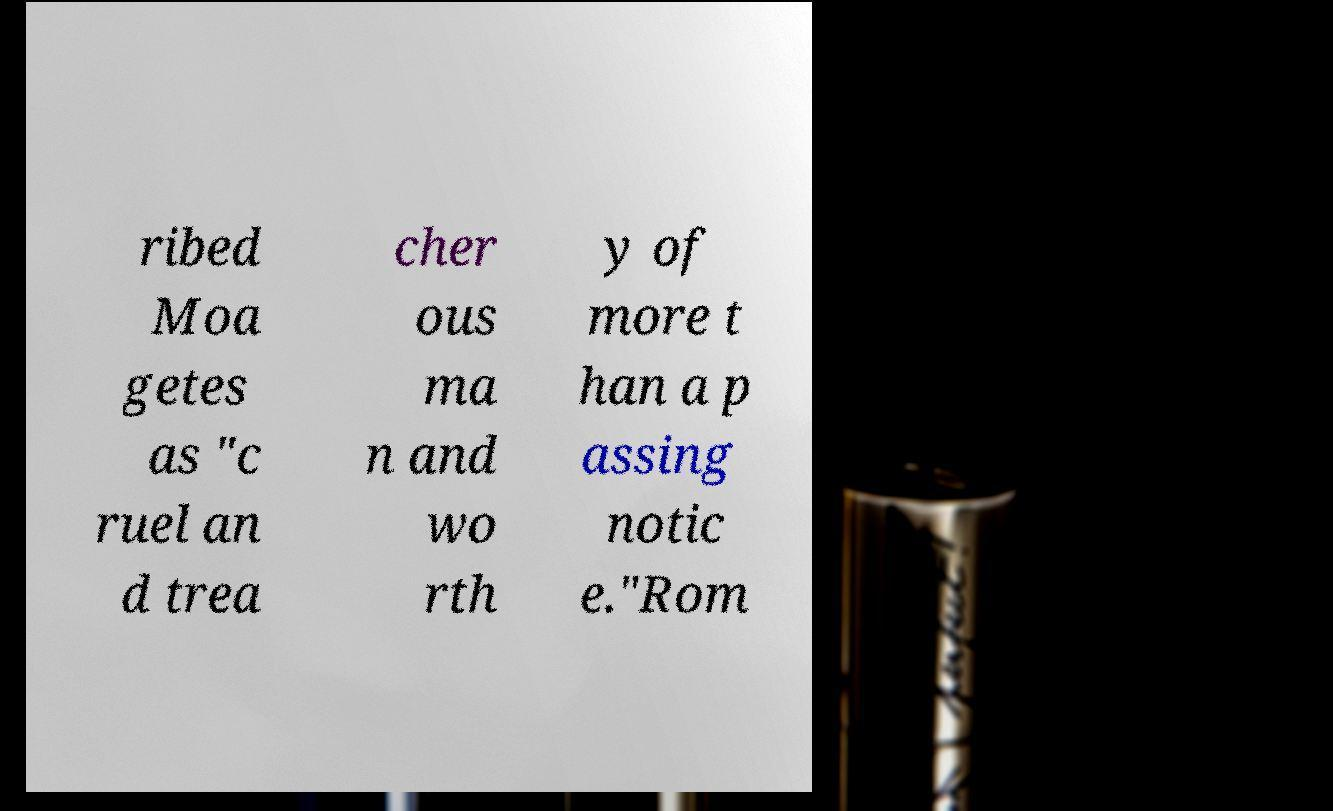What messages or text are displayed in this image? I need them in a readable, typed format. ribed Moa getes as "c ruel an d trea cher ous ma n and wo rth y of more t han a p assing notic e."Rom 